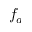<formula> <loc_0><loc_0><loc_500><loc_500>f _ { a }</formula> 